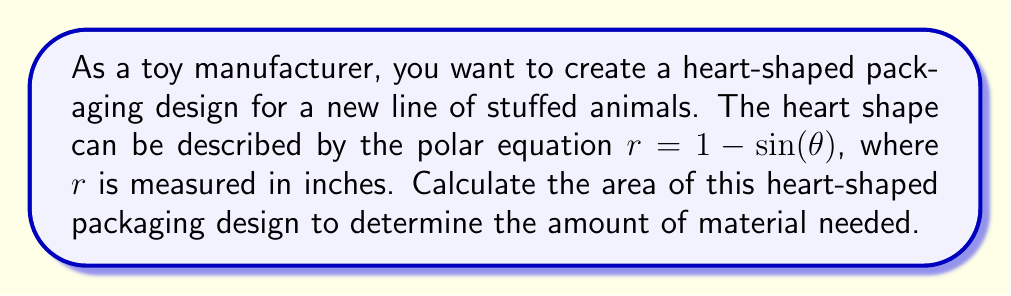Help me with this question. To calculate the area of the heart-shaped packaging design, we need to use the formula for area in polar coordinates:

$$A = \frac{1}{2} \int_{0}^{2\pi} r^2 d\theta$$

Given the polar equation $r = 1 - \sin(\theta)$, we can substitute this into our area formula:

$$A = \frac{1}{2} \int_{0}^{2\pi} (1 - \sin(\theta))^2 d\theta$$

Expanding the squared term:
$$(1 - \sin(\theta))^2 = 1 - 2\sin(\theta) + \sin^2(\theta)$$

Substituting back into our integral:

$$A = \frac{1}{2} \int_{0}^{2\pi} (1 - 2\sin(\theta) + \sin^2(\theta)) d\theta$$

Now, let's evaluate each part of the integral:

1. $\int_{0}^{2\pi} 1 d\theta = 2\pi$
2. $\int_{0}^{2\pi} -2\sin(\theta) d\theta = 2\cos(\theta)|_{0}^{2\pi} = 0$
3. $\int_{0}^{2\pi} \sin^2(\theta) d\theta = \int_{0}^{2\pi} \frac{1 - \cos(2\theta)}{2} d\theta = \pi - \frac{1}{2}\sin(2\theta)|_{0}^{2\pi} = \pi$

Adding these results and multiplying by $\frac{1}{2}$:

$$A = \frac{1}{2}(2\pi + 0 + \pi) = \frac{3\pi}{2}$$

Therefore, the area of the heart-shaped packaging design is $\frac{3\pi}{2}$ square inches.
Answer: $\frac{3\pi}{2}$ square inches 